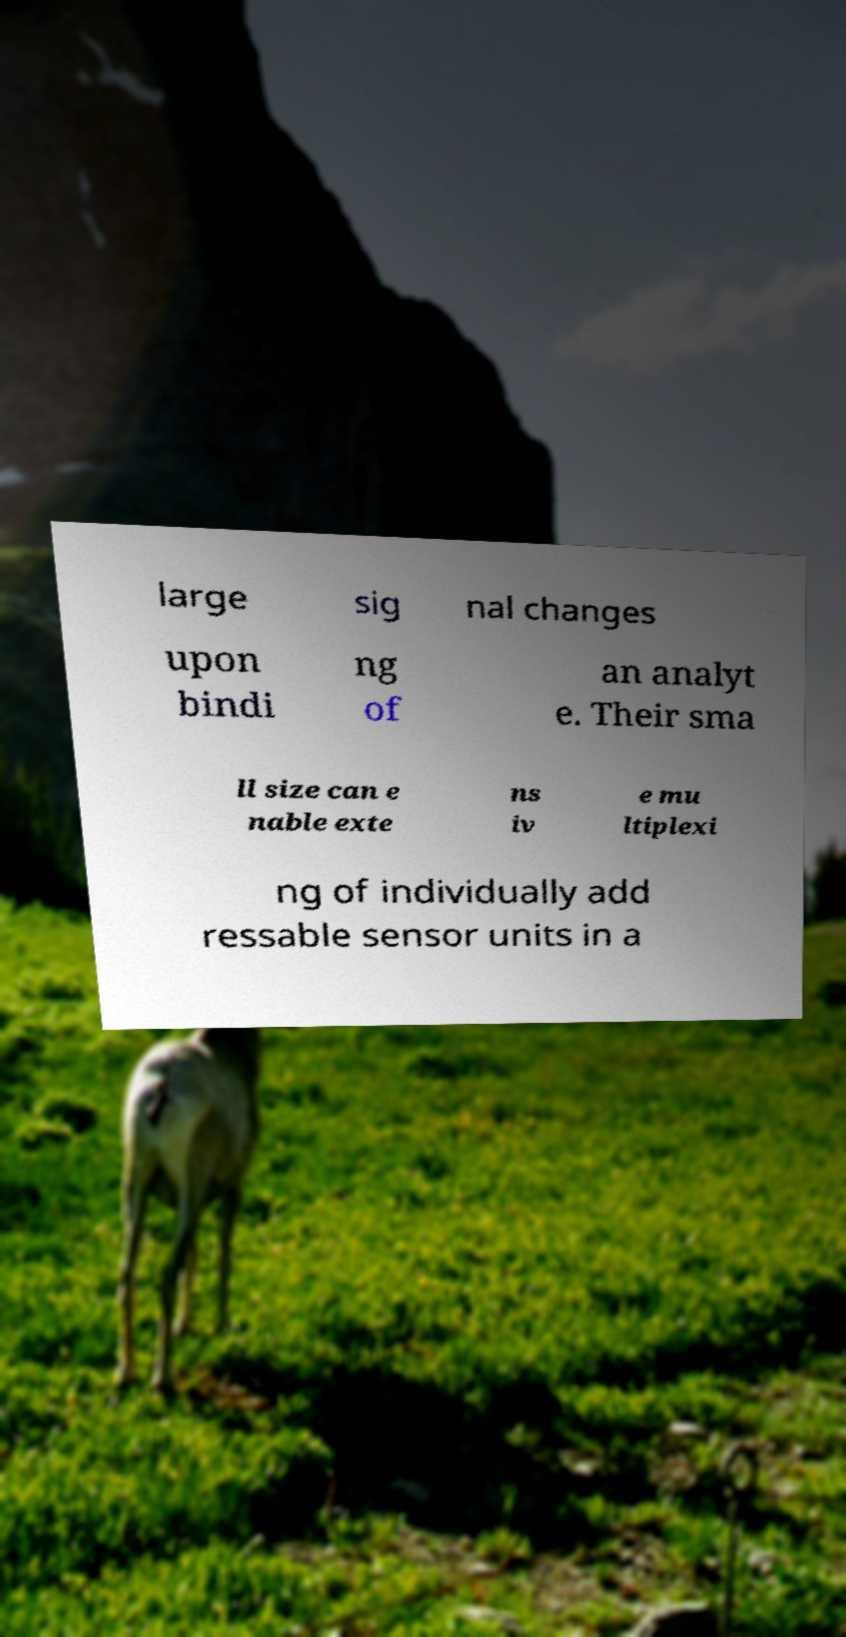I need the written content from this picture converted into text. Can you do that? large sig nal changes upon bindi ng of an analyt e. Their sma ll size can e nable exte ns iv e mu ltiplexi ng of individually add ressable sensor units in a 